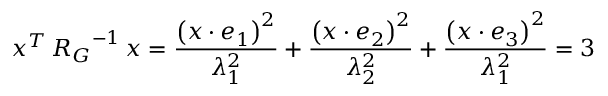<formula> <loc_0><loc_0><loc_500><loc_500>x ^ { T } \, R _ { G } ^ { - 1 } \, x = \frac { \left ( x \cdot e _ { 1 } \right ) ^ { 2 } } { \lambda _ { 1 } ^ { 2 } } + \frac { \left ( x \cdot e _ { 2 } \right ) ^ { 2 } } { \lambda _ { 2 } ^ { 2 } } + \frac { \left ( x \cdot e _ { 3 } \right ) ^ { 2 } } { \lambda _ { 1 } ^ { 2 } } = 3</formula> 